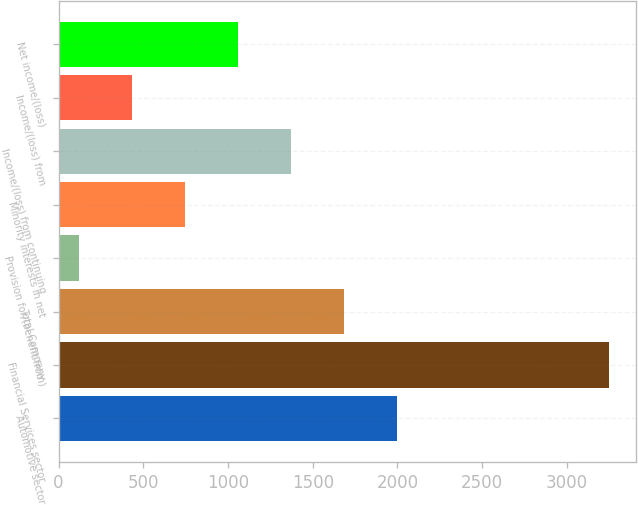Convert chart to OTSL. <chart><loc_0><loc_0><loc_500><loc_500><bar_chart><fcel>Automotive sector<fcel>Financial Services sector<fcel>Total Company<fcel>Provision for/(benefit from)<fcel>Minority interests in net<fcel>Income/(loss) from continuing<fcel>Income/(loss) from<fcel>Net income/(loss)<nl><fcel>1997.4<fcel>3247<fcel>1685<fcel>123<fcel>747.8<fcel>1372.6<fcel>435.4<fcel>1060.2<nl></chart> 